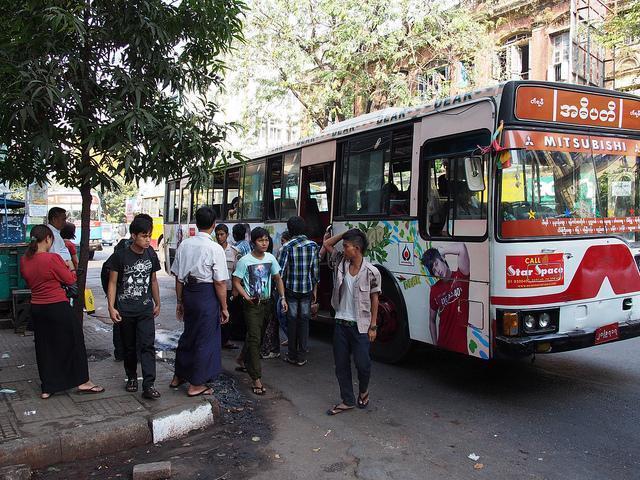How many people are in the picture?
Give a very brief answer. 11. How many people are visible?
Give a very brief answer. 6. 